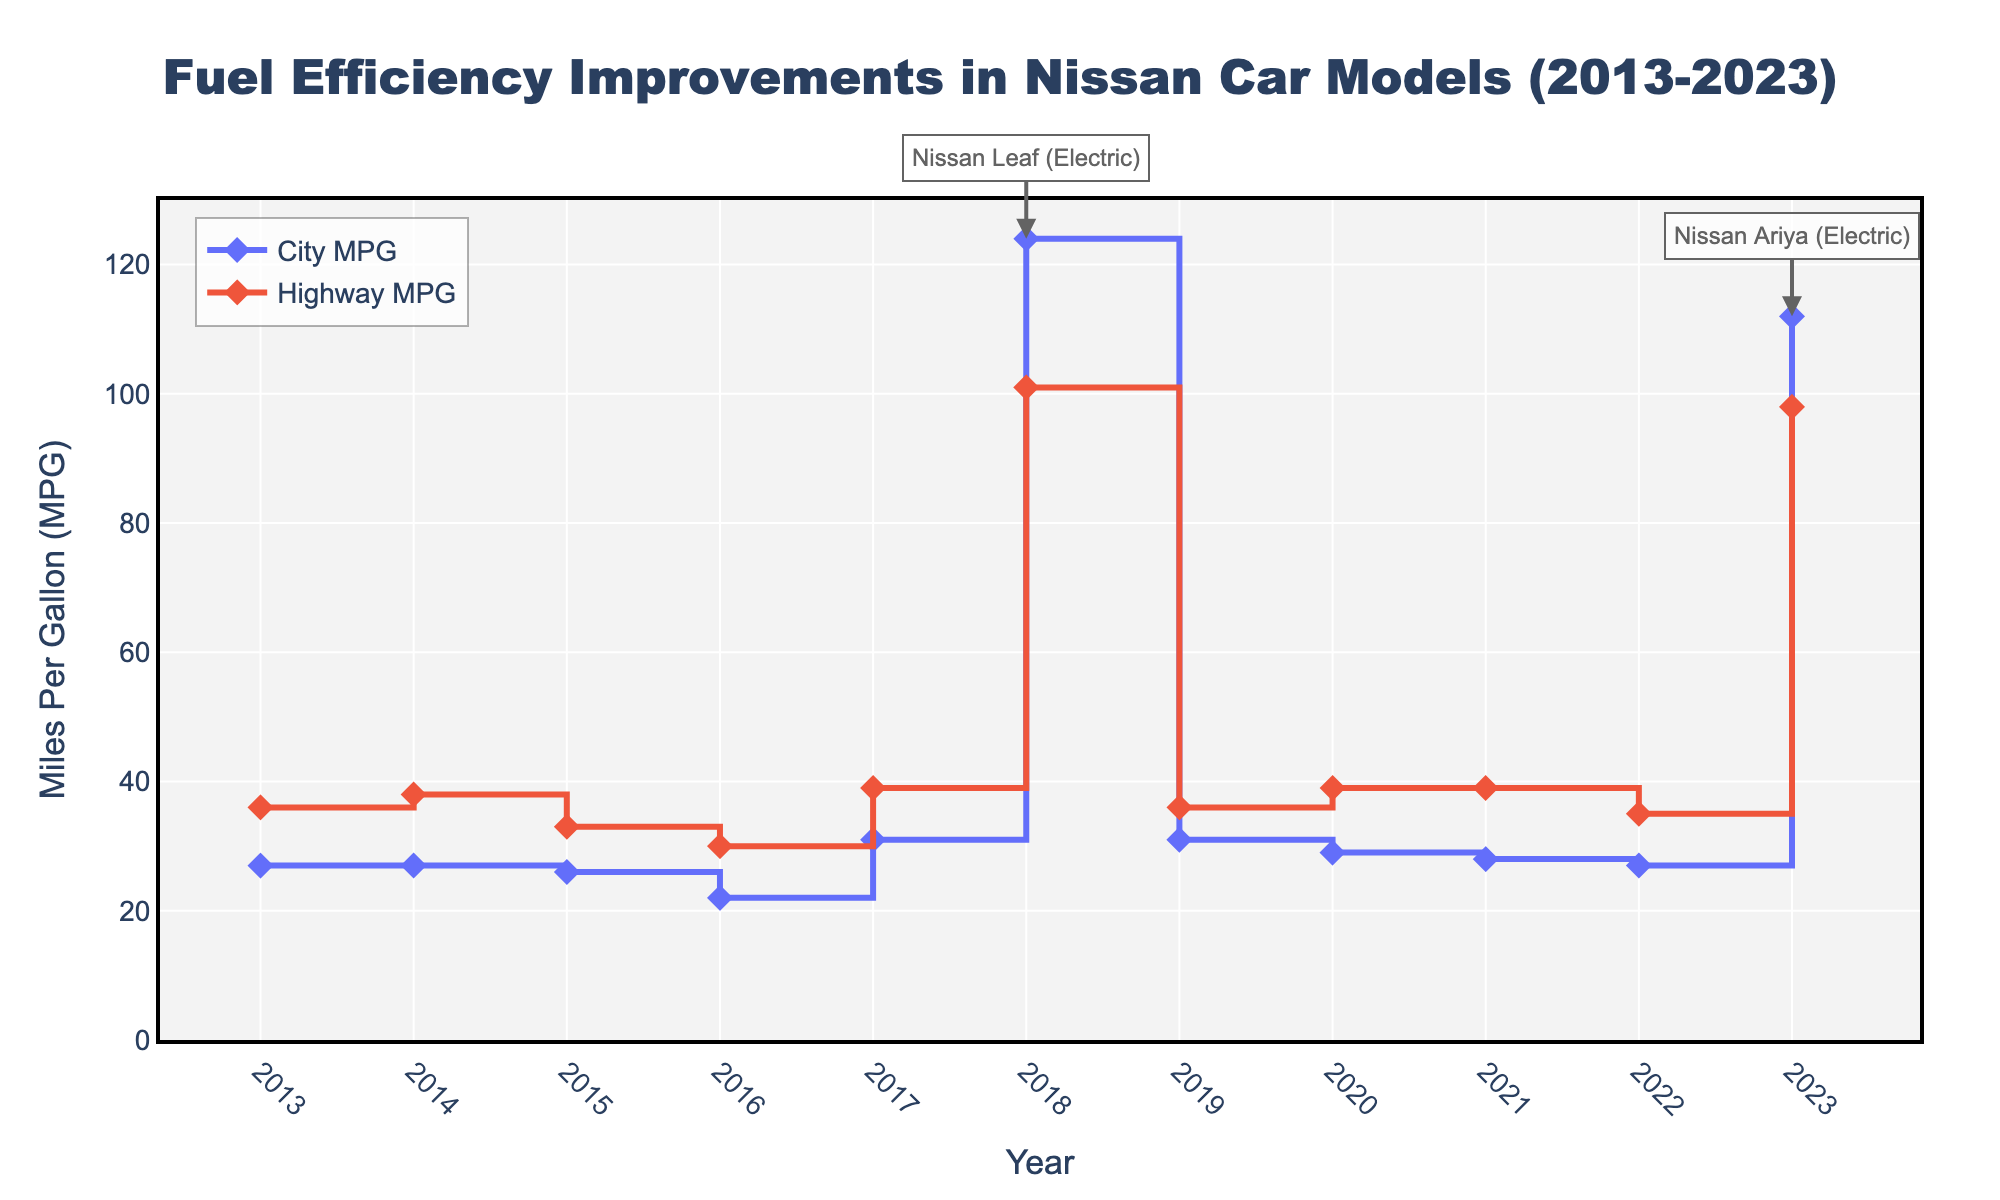What's the title of the figure? Locate the title at the top center of the figure. It should be in large, bold font.
Answer: Fuel Efficiency Improvements in Nissan Car Models (2013-2023) What is the range of the y-axis in terms of MPG? The y-axis is labeled "Miles Per Gallon (MPG)" and the range is indicated by the axis ticks.
Answer: 0 to 130 Which car model had the highest city MPG in 2018? Identify the peak value in the MPG_City line for the year 2018 and check the hover details for that data point.
Answer: Nissan Leaf How did the city MPG of the Nissan Sentra change from 2013 to 2020? Find the values for MPG_City for the Nissan Sentra in both 2013 and 2020 and then compute the difference between them.
Answer: Increased from 27 to 29 Which years show electric models based on their city MPG values? Look for the annotation and data points where the MPG_City exceeds 100.
Answer: 2018 and 2023 Compare the highway MPG of the Nissan Altima in 2014 and 2021. Which year had better efficiency? Refer to the highway MPG value for the Nissan Altima in both years and compare them.
Answer: 2021 (39 MPG) What is the trend in city MPG for Nissan Rogue from 2015 to 2022? Observe the data points for Nissan Rogue from 2015 to 2022 and describe the pattern of increase or decrease.
Answer: Generally decreased Which car model in 2023 has lower highway MPG compared to its city MPG? In 2023, look for the model with an uncommonly higher city MPG than highway MPG. Verify it's not an electric vehicle.
Answer: Nissan Ariya What is the average highway MPG for the years 2013 and 2023 combined? Add the highway MPG values for both years (36 for 2013 and 98 for 2023) and divide by 2.
Answer: 67 Among the listed models, which one had the highest highway MPG improvement when comparing its first and last year in the dataset? Identify the years each model appears first and last, then compute the difference in highway MPG and compare across all models.
Answer: Nissan Leaf (75 MPG improvement, from 36 in 2013 to 101 in 2018) 